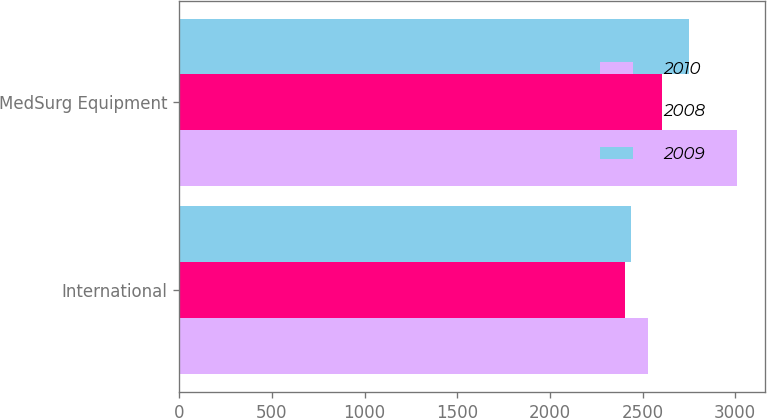Convert chart to OTSL. <chart><loc_0><loc_0><loc_500><loc_500><stacked_bar_chart><ecel><fcel>International<fcel>MedSurg Equipment<nl><fcel>2010<fcel>2527.2<fcel>3011.6<nl><fcel>2008<fcel>2405.7<fcel>2603.4<nl><fcel>2009<fcel>2436<fcel>2750.7<nl></chart> 